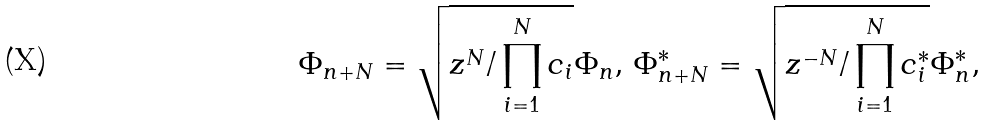Convert formula to latex. <formula><loc_0><loc_0><loc_500><loc_500>\Phi _ { n + N } = \sqrt { z ^ { N } / \prod _ { i = 1 } ^ { N } c _ { i } } \Phi _ { n } , \, \Phi _ { n + N } ^ { * } = \sqrt { z ^ { - N } / \prod _ { i = 1 } ^ { N } c _ { i } ^ { * } } \Phi _ { n } ^ { * } ,</formula> 